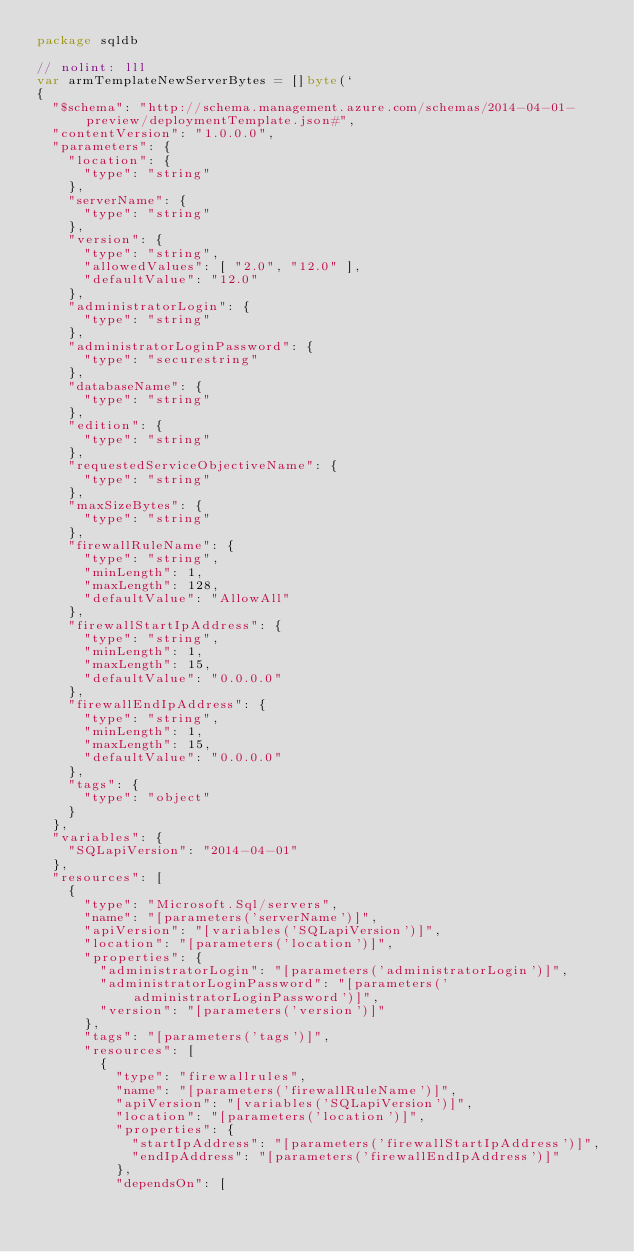Convert code to text. <code><loc_0><loc_0><loc_500><loc_500><_Go_>package sqldb

// nolint: lll
var armTemplateNewServerBytes = []byte(`
{
	"$schema": "http://schema.management.azure.com/schemas/2014-04-01-preview/deploymentTemplate.json#",
	"contentVersion": "1.0.0.0",
	"parameters": {
		"location": {
			"type": "string"
		},
		"serverName": {
			"type": "string"
		},
		"version": {
			"type": "string",
			"allowedValues": [ "2.0", "12.0" ],
			"defaultValue": "12.0"
		},
		"administratorLogin": {
			"type": "string"
		},
		"administratorLoginPassword": {
			"type": "securestring"
		},
		"databaseName": {
			"type": "string"
		},
		"edition": {
			"type": "string"
		},
		"requestedServiceObjectiveName": {
			"type": "string"
		},
		"maxSizeBytes": {
			"type": "string"
		},
		"firewallRuleName": {
			"type": "string",
			"minLength": 1,
			"maxLength": 128,
			"defaultValue": "AllowAll"
		},
		"firewallStartIpAddress": {
			"type": "string",
			"minLength": 1,
			"maxLength": 15,
			"defaultValue": "0.0.0.0"
		},
		"firewallEndIpAddress": {
			"type": "string",
			"minLength": 1,
			"maxLength": 15,
			"defaultValue": "0.0.0.0"
		},
		"tags": {
			"type": "object"
		}
	},
	"variables": {
		"SQLapiVersion": "2014-04-01"
	},
	"resources": [
		{
			"type": "Microsoft.Sql/servers",
			"name": "[parameters('serverName')]",
			"apiVersion": "[variables('SQLapiVersion')]",
			"location": "[parameters('location')]",
			"properties": {
				"administratorLogin": "[parameters('administratorLogin')]",
				"administratorLoginPassword": "[parameters('administratorLoginPassword')]",
				"version": "[parameters('version')]"
			},
			"tags": "[parameters('tags')]",
			"resources": [
				{
					"type": "firewallrules",
					"name": "[parameters('firewallRuleName')]",
					"apiVersion": "[variables('SQLapiVersion')]",
					"location": "[parameters('location')]",
					"properties": {
						"startIpAddress": "[parameters('firewallStartIpAddress')]",
						"endIpAddress": "[parameters('firewallEndIpAddress')]"
					},
					"dependsOn": [</code> 